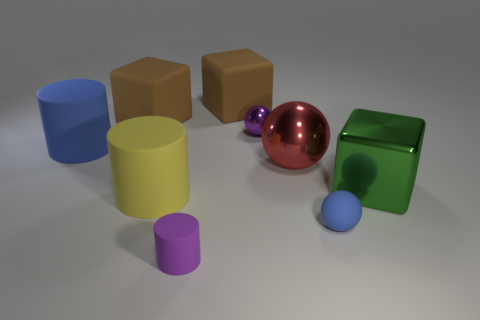What can you tell me about the colors and textures of the objects? The objects presented in the image have a variety of colors and exhibit diverse textures. The cylinders and spheres are smooth and glossy, with the red sphere in particular having a reflective surface that mirrors its surroundings. The cubes, in contrast, are matte with the light diffusing evenly on their surfaces. The color palette includes blue, purple, yellow, tan, red, and green, which provides a vibrant contrast between the cool and warm tones. This mix of colors and textures creates an interesting visual dynamic in the scene.  How do the lighting and shadows contribute to the image? The lighting in the image is soft and appears to come from above, casting gently diffused shadows underneath each object. These shadows ground the objects and give a sense of their three-dimensional form in the space. The light source produces subtle highlights on the reflective surfaces, especially noticeable on the red sphere and the blue cylinder, which enhance their glossy textures. Overall, the lighting and shadows add depth and realism to the scene, helping to distinguish the textures and forms of the objects. 